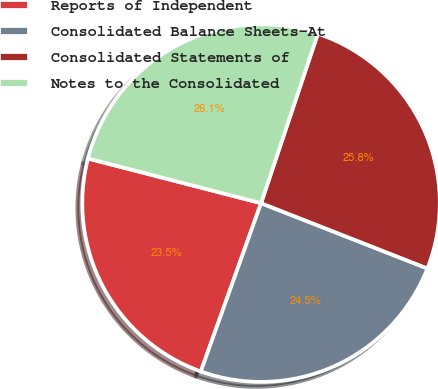Convert chart to OTSL. <chart><loc_0><loc_0><loc_500><loc_500><pie_chart><fcel>Reports of Independent<fcel>Consolidated Balance Sheets-At<fcel>Consolidated Statements of<fcel>Notes to the Consolidated<nl><fcel>23.55%<fcel>24.52%<fcel>25.81%<fcel>26.13%<nl></chart> 